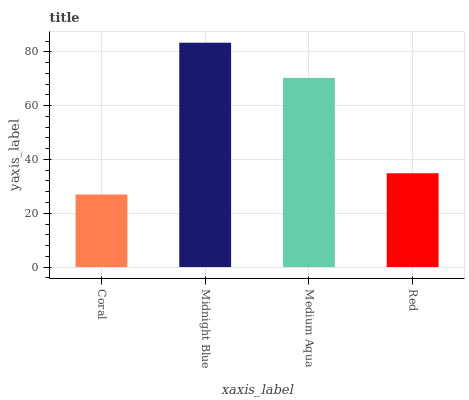Is Coral the minimum?
Answer yes or no. Yes. Is Midnight Blue the maximum?
Answer yes or no. Yes. Is Medium Aqua the minimum?
Answer yes or no. No. Is Medium Aqua the maximum?
Answer yes or no. No. Is Midnight Blue greater than Medium Aqua?
Answer yes or no. Yes. Is Medium Aqua less than Midnight Blue?
Answer yes or no. Yes. Is Medium Aqua greater than Midnight Blue?
Answer yes or no. No. Is Midnight Blue less than Medium Aqua?
Answer yes or no. No. Is Medium Aqua the high median?
Answer yes or no. Yes. Is Red the low median?
Answer yes or no. Yes. Is Red the high median?
Answer yes or no. No. Is Midnight Blue the low median?
Answer yes or no. No. 